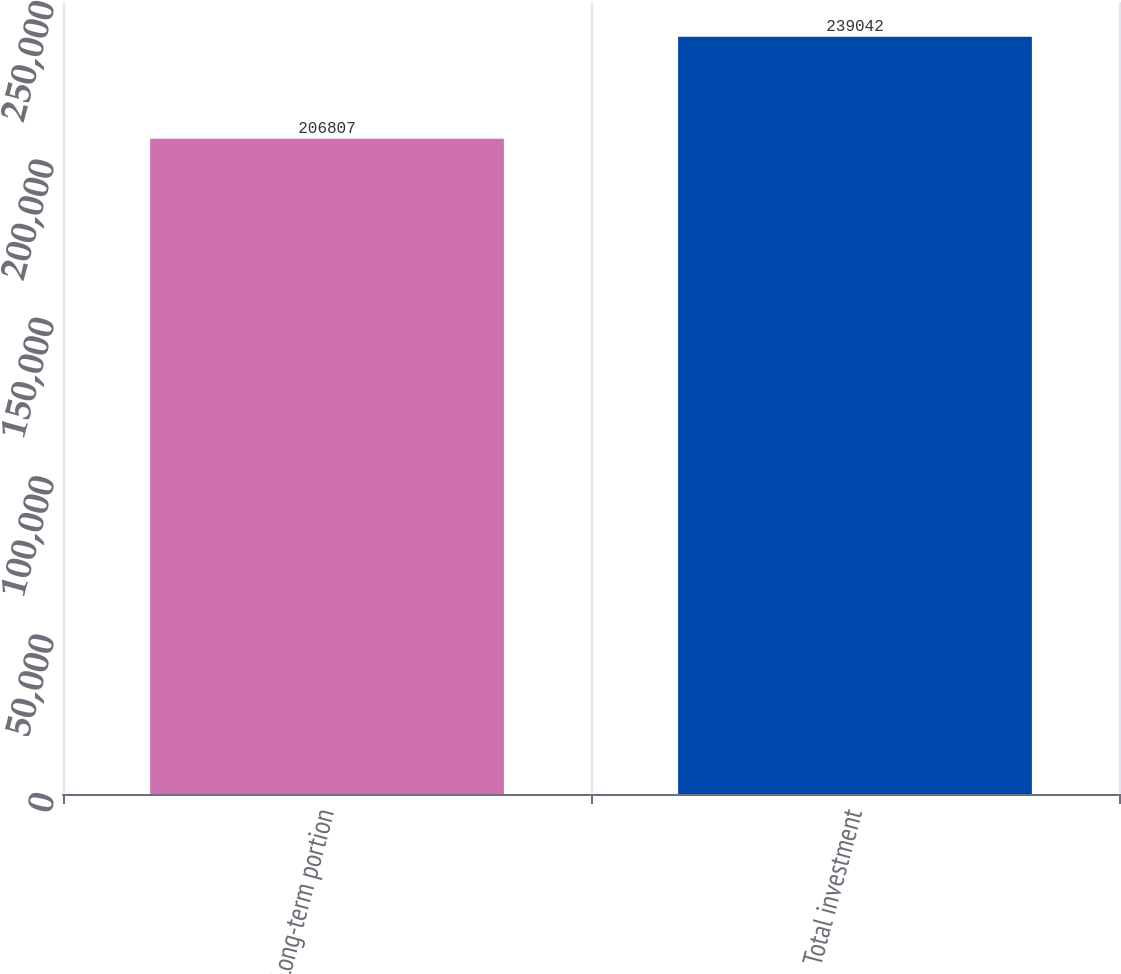Convert chart. <chart><loc_0><loc_0><loc_500><loc_500><bar_chart><fcel>Long-term portion<fcel>Total investment<nl><fcel>206807<fcel>239042<nl></chart> 